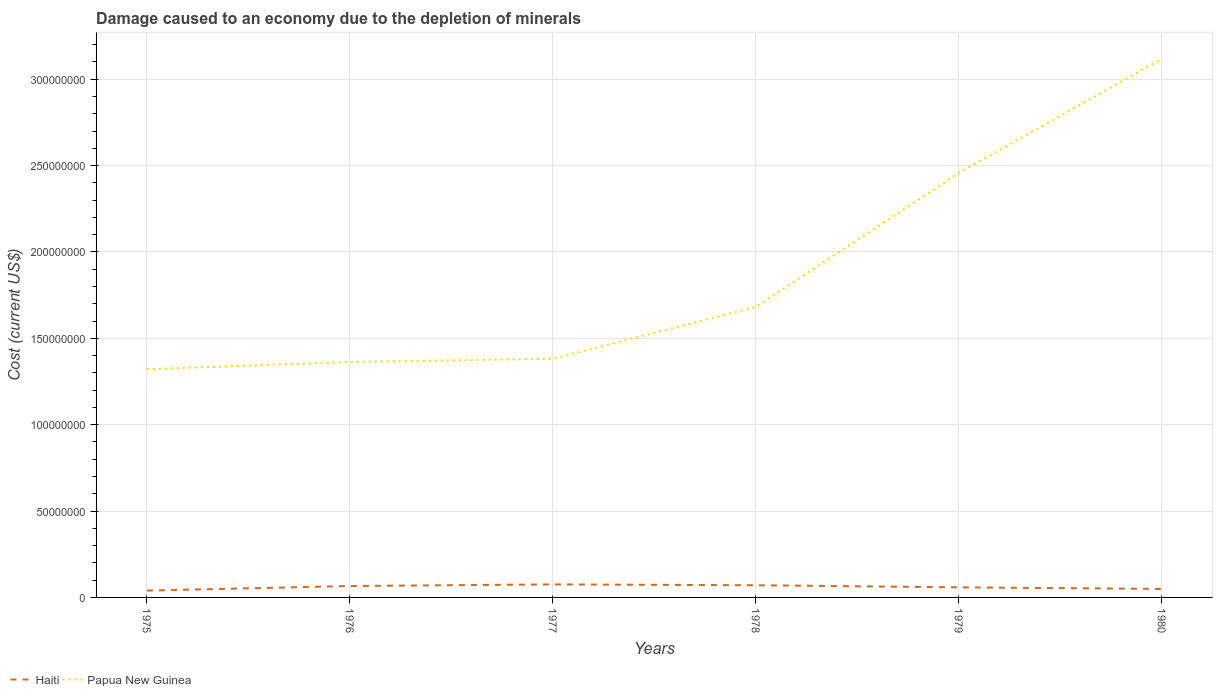How many different coloured lines are there?
Your response must be concise. 2. Does the line corresponding to Papua New Guinea intersect with the line corresponding to Haiti?
Keep it short and to the point. No. Across all years, what is the maximum cost of damage caused due to the depletion of minerals in Papua New Guinea?
Provide a short and direct response. 1.32e+08. In which year was the cost of damage caused due to the depletion of minerals in Papua New Guinea maximum?
Make the answer very short. 1975. What is the total cost of damage caused due to the depletion of minerals in Papua New Guinea in the graph?
Provide a short and direct response. -1.87e+06. What is the difference between the highest and the second highest cost of damage caused due to the depletion of minerals in Haiti?
Give a very brief answer. 3.57e+06. Is the cost of damage caused due to the depletion of minerals in Papua New Guinea strictly greater than the cost of damage caused due to the depletion of minerals in Haiti over the years?
Keep it short and to the point. No. How many years are there in the graph?
Your response must be concise. 6. Are the values on the major ticks of Y-axis written in scientific E-notation?
Ensure brevity in your answer.  No. Does the graph contain grids?
Ensure brevity in your answer.  Yes. What is the title of the graph?
Keep it short and to the point. Damage caused to an economy due to the depletion of minerals. What is the label or title of the Y-axis?
Provide a succinct answer. Cost (current US$). What is the Cost (current US$) in Haiti in 1975?
Your answer should be compact. 3.97e+06. What is the Cost (current US$) in Papua New Guinea in 1975?
Offer a terse response. 1.32e+08. What is the Cost (current US$) in Haiti in 1976?
Your answer should be compact. 6.60e+06. What is the Cost (current US$) of Papua New Guinea in 1976?
Provide a short and direct response. 1.36e+08. What is the Cost (current US$) of Haiti in 1977?
Provide a succinct answer. 7.54e+06. What is the Cost (current US$) in Papua New Guinea in 1977?
Your answer should be compact. 1.38e+08. What is the Cost (current US$) of Haiti in 1978?
Provide a short and direct response. 7.06e+06. What is the Cost (current US$) in Papua New Guinea in 1978?
Offer a very short reply. 1.68e+08. What is the Cost (current US$) in Haiti in 1979?
Offer a very short reply. 5.84e+06. What is the Cost (current US$) in Papua New Guinea in 1979?
Offer a terse response. 2.46e+08. What is the Cost (current US$) in Haiti in 1980?
Ensure brevity in your answer.  4.93e+06. What is the Cost (current US$) in Papua New Guinea in 1980?
Your response must be concise. 3.12e+08. Across all years, what is the maximum Cost (current US$) in Haiti?
Offer a terse response. 7.54e+06. Across all years, what is the maximum Cost (current US$) in Papua New Guinea?
Your response must be concise. 3.12e+08. Across all years, what is the minimum Cost (current US$) of Haiti?
Offer a very short reply. 3.97e+06. Across all years, what is the minimum Cost (current US$) of Papua New Guinea?
Your answer should be compact. 1.32e+08. What is the total Cost (current US$) of Haiti in the graph?
Ensure brevity in your answer.  3.59e+07. What is the total Cost (current US$) of Papua New Guinea in the graph?
Your answer should be very brief. 1.13e+09. What is the difference between the Cost (current US$) in Haiti in 1975 and that in 1976?
Provide a short and direct response. -2.63e+06. What is the difference between the Cost (current US$) of Papua New Guinea in 1975 and that in 1976?
Provide a succinct answer. -4.20e+06. What is the difference between the Cost (current US$) of Haiti in 1975 and that in 1977?
Your answer should be very brief. -3.57e+06. What is the difference between the Cost (current US$) in Papua New Guinea in 1975 and that in 1977?
Your response must be concise. -6.07e+06. What is the difference between the Cost (current US$) of Haiti in 1975 and that in 1978?
Ensure brevity in your answer.  -3.09e+06. What is the difference between the Cost (current US$) of Papua New Guinea in 1975 and that in 1978?
Ensure brevity in your answer.  -3.60e+07. What is the difference between the Cost (current US$) of Haiti in 1975 and that in 1979?
Provide a short and direct response. -1.87e+06. What is the difference between the Cost (current US$) in Papua New Guinea in 1975 and that in 1979?
Offer a terse response. -1.14e+08. What is the difference between the Cost (current US$) in Haiti in 1975 and that in 1980?
Offer a very short reply. -9.56e+05. What is the difference between the Cost (current US$) of Papua New Guinea in 1975 and that in 1980?
Your answer should be very brief. -1.80e+08. What is the difference between the Cost (current US$) of Haiti in 1976 and that in 1977?
Provide a short and direct response. -9.38e+05. What is the difference between the Cost (current US$) of Papua New Guinea in 1976 and that in 1977?
Give a very brief answer. -1.87e+06. What is the difference between the Cost (current US$) in Haiti in 1976 and that in 1978?
Give a very brief answer. -4.54e+05. What is the difference between the Cost (current US$) in Papua New Guinea in 1976 and that in 1978?
Give a very brief answer. -3.18e+07. What is the difference between the Cost (current US$) of Haiti in 1976 and that in 1979?
Provide a short and direct response. 7.59e+05. What is the difference between the Cost (current US$) in Papua New Guinea in 1976 and that in 1979?
Offer a terse response. -1.09e+08. What is the difference between the Cost (current US$) in Haiti in 1976 and that in 1980?
Give a very brief answer. 1.67e+06. What is the difference between the Cost (current US$) of Papua New Guinea in 1976 and that in 1980?
Provide a short and direct response. -1.75e+08. What is the difference between the Cost (current US$) of Haiti in 1977 and that in 1978?
Your answer should be compact. 4.83e+05. What is the difference between the Cost (current US$) in Papua New Guinea in 1977 and that in 1978?
Your answer should be very brief. -3.00e+07. What is the difference between the Cost (current US$) of Haiti in 1977 and that in 1979?
Give a very brief answer. 1.70e+06. What is the difference between the Cost (current US$) of Papua New Guinea in 1977 and that in 1979?
Provide a succinct answer. -1.08e+08. What is the difference between the Cost (current US$) of Haiti in 1977 and that in 1980?
Make the answer very short. 2.61e+06. What is the difference between the Cost (current US$) in Papua New Guinea in 1977 and that in 1980?
Your answer should be compact. -1.74e+08. What is the difference between the Cost (current US$) of Haiti in 1978 and that in 1979?
Offer a very short reply. 1.21e+06. What is the difference between the Cost (current US$) in Papua New Guinea in 1978 and that in 1979?
Make the answer very short. -7.76e+07. What is the difference between the Cost (current US$) of Haiti in 1978 and that in 1980?
Provide a short and direct response. 2.13e+06. What is the difference between the Cost (current US$) in Papua New Guinea in 1978 and that in 1980?
Provide a succinct answer. -1.44e+08. What is the difference between the Cost (current US$) in Haiti in 1979 and that in 1980?
Make the answer very short. 9.16e+05. What is the difference between the Cost (current US$) in Papua New Guinea in 1979 and that in 1980?
Keep it short and to the point. -6.61e+07. What is the difference between the Cost (current US$) of Haiti in 1975 and the Cost (current US$) of Papua New Guinea in 1976?
Provide a short and direct response. -1.32e+08. What is the difference between the Cost (current US$) of Haiti in 1975 and the Cost (current US$) of Papua New Guinea in 1977?
Offer a terse response. -1.34e+08. What is the difference between the Cost (current US$) in Haiti in 1975 and the Cost (current US$) in Papua New Guinea in 1978?
Provide a short and direct response. -1.64e+08. What is the difference between the Cost (current US$) in Haiti in 1975 and the Cost (current US$) in Papua New Guinea in 1979?
Make the answer very short. -2.42e+08. What is the difference between the Cost (current US$) of Haiti in 1975 and the Cost (current US$) of Papua New Guinea in 1980?
Provide a short and direct response. -3.08e+08. What is the difference between the Cost (current US$) in Haiti in 1976 and the Cost (current US$) in Papua New Guinea in 1977?
Your answer should be compact. -1.32e+08. What is the difference between the Cost (current US$) in Haiti in 1976 and the Cost (current US$) in Papua New Guinea in 1978?
Your answer should be compact. -1.62e+08. What is the difference between the Cost (current US$) in Haiti in 1976 and the Cost (current US$) in Papua New Guinea in 1979?
Your response must be concise. -2.39e+08. What is the difference between the Cost (current US$) of Haiti in 1976 and the Cost (current US$) of Papua New Guinea in 1980?
Offer a very short reply. -3.05e+08. What is the difference between the Cost (current US$) of Haiti in 1977 and the Cost (current US$) of Papua New Guinea in 1978?
Keep it short and to the point. -1.61e+08. What is the difference between the Cost (current US$) of Haiti in 1977 and the Cost (current US$) of Papua New Guinea in 1979?
Give a very brief answer. -2.38e+08. What is the difference between the Cost (current US$) in Haiti in 1977 and the Cost (current US$) in Papua New Guinea in 1980?
Offer a terse response. -3.04e+08. What is the difference between the Cost (current US$) of Haiti in 1978 and the Cost (current US$) of Papua New Guinea in 1979?
Offer a very short reply. -2.39e+08. What is the difference between the Cost (current US$) in Haiti in 1978 and the Cost (current US$) in Papua New Guinea in 1980?
Offer a terse response. -3.05e+08. What is the difference between the Cost (current US$) of Haiti in 1979 and the Cost (current US$) of Papua New Guinea in 1980?
Ensure brevity in your answer.  -3.06e+08. What is the average Cost (current US$) in Haiti per year?
Offer a very short reply. 5.99e+06. What is the average Cost (current US$) in Papua New Guinea per year?
Your answer should be very brief. 1.89e+08. In the year 1975, what is the difference between the Cost (current US$) in Haiti and Cost (current US$) in Papua New Guinea?
Your answer should be very brief. -1.28e+08. In the year 1976, what is the difference between the Cost (current US$) of Haiti and Cost (current US$) of Papua New Guinea?
Your answer should be very brief. -1.30e+08. In the year 1977, what is the difference between the Cost (current US$) in Haiti and Cost (current US$) in Papua New Guinea?
Give a very brief answer. -1.31e+08. In the year 1978, what is the difference between the Cost (current US$) in Haiti and Cost (current US$) in Papua New Guinea?
Offer a very short reply. -1.61e+08. In the year 1979, what is the difference between the Cost (current US$) of Haiti and Cost (current US$) of Papua New Guinea?
Offer a very short reply. -2.40e+08. In the year 1980, what is the difference between the Cost (current US$) in Haiti and Cost (current US$) in Papua New Guinea?
Offer a very short reply. -3.07e+08. What is the ratio of the Cost (current US$) of Haiti in 1975 to that in 1976?
Offer a terse response. 0.6. What is the ratio of the Cost (current US$) of Papua New Guinea in 1975 to that in 1976?
Offer a very short reply. 0.97. What is the ratio of the Cost (current US$) in Haiti in 1975 to that in 1977?
Provide a succinct answer. 0.53. What is the ratio of the Cost (current US$) in Papua New Guinea in 1975 to that in 1977?
Give a very brief answer. 0.96. What is the ratio of the Cost (current US$) of Haiti in 1975 to that in 1978?
Offer a terse response. 0.56. What is the ratio of the Cost (current US$) of Papua New Guinea in 1975 to that in 1978?
Keep it short and to the point. 0.79. What is the ratio of the Cost (current US$) in Haiti in 1975 to that in 1979?
Your answer should be compact. 0.68. What is the ratio of the Cost (current US$) of Papua New Guinea in 1975 to that in 1979?
Ensure brevity in your answer.  0.54. What is the ratio of the Cost (current US$) of Haiti in 1975 to that in 1980?
Offer a terse response. 0.81. What is the ratio of the Cost (current US$) of Papua New Guinea in 1975 to that in 1980?
Your answer should be compact. 0.42. What is the ratio of the Cost (current US$) of Haiti in 1976 to that in 1977?
Your answer should be very brief. 0.88. What is the ratio of the Cost (current US$) of Papua New Guinea in 1976 to that in 1977?
Your response must be concise. 0.99. What is the ratio of the Cost (current US$) in Haiti in 1976 to that in 1978?
Provide a short and direct response. 0.94. What is the ratio of the Cost (current US$) of Papua New Guinea in 1976 to that in 1978?
Provide a succinct answer. 0.81. What is the ratio of the Cost (current US$) in Haiti in 1976 to that in 1979?
Keep it short and to the point. 1.13. What is the ratio of the Cost (current US$) of Papua New Guinea in 1976 to that in 1979?
Provide a short and direct response. 0.55. What is the ratio of the Cost (current US$) in Haiti in 1976 to that in 1980?
Your answer should be compact. 1.34. What is the ratio of the Cost (current US$) in Papua New Guinea in 1976 to that in 1980?
Keep it short and to the point. 0.44. What is the ratio of the Cost (current US$) in Haiti in 1977 to that in 1978?
Your answer should be very brief. 1.07. What is the ratio of the Cost (current US$) in Papua New Guinea in 1977 to that in 1978?
Give a very brief answer. 0.82. What is the ratio of the Cost (current US$) in Haiti in 1977 to that in 1979?
Your response must be concise. 1.29. What is the ratio of the Cost (current US$) of Papua New Guinea in 1977 to that in 1979?
Your answer should be compact. 0.56. What is the ratio of the Cost (current US$) of Haiti in 1977 to that in 1980?
Offer a very short reply. 1.53. What is the ratio of the Cost (current US$) in Papua New Guinea in 1977 to that in 1980?
Your answer should be compact. 0.44. What is the ratio of the Cost (current US$) in Haiti in 1978 to that in 1979?
Provide a succinct answer. 1.21. What is the ratio of the Cost (current US$) of Papua New Guinea in 1978 to that in 1979?
Provide a short and direct response. 0.68. What is the ratio of the Cost (current US$) in Haiti in 1978 to that in 1980?
Give a very brief answer. 1.43. What is the ratio of the Cost (current US$) in Papua New Guinea in 1978 to that in 1980?
Your response must be concise. 0.54. What is the ratio of the Cost (current US$) of Haiti in 1979 to that in 1980?
Provide a short and direct response. 1.19. What is the ratio of the Cost (current US$) in Papua New Guinea in 1979 to that in 1980?
Your answer should be compact. 0.79. What is the difference between the highest and the second highest Cost (current US$) of Haiti?
Make the answer very short. 4.83e+05. What is the difference between the highest and the second highest Cost (current US$) in Papua New Guinea?
Give a very brief answer. 6.61e+07. What is the difference between the highest and the lowest Cost (current US$) in Haiti?
Ensure brevity in your answer.  3.57e+06. What is the difference between the highest and the lowest Cost (current US$) of Papua New Guinea?
Make the answer very short. 1.80e+08. 